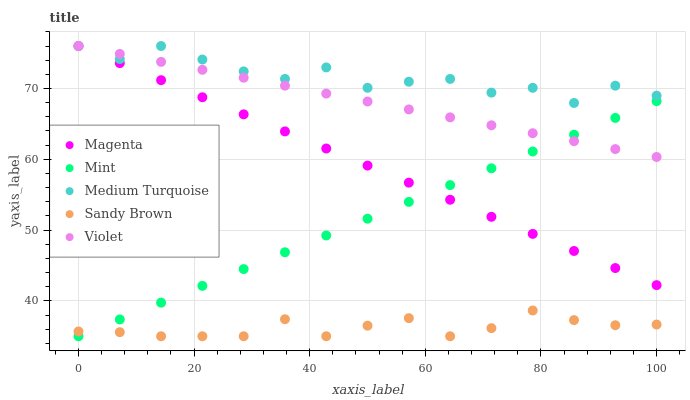Does Sandy Brown have the minimum area under the curve?
Answer yes or no. Yes. Does Medium Turquoise have the maximum area under the curve?
Answer yes or no. Yes. Does Magenta have the minimum area under the curve?
Answer yes or no. No. Does Magenta have the maximum area under the curve?
Answer yes or no. No. Is Magenta the smoothest?
Answer yes or no. Yes. Is Medium Turquoise the roughest?
Answer yes or no. Yes. Is Mint the smoothest?
Answer yes or no. No. Is Mint the roughest?
Answer yes or no. No. Does Sandy Brown have the lowest value?
Answer yes or no. Yes. Does Magenta have the lowest value?
Answer yes or no. No. Does Violet have the highest value?
Answer yes or no. Yes. Does Mint have the highest value?
Answer yes or no. No. Is Sandy Brown less than Violet?
Answer yes or no. Yes. Is Medium Turquoise greater than Sandy Brown?
Answer yes or no. Yes. Does Mint intersect Violet?
Answer yes or no. Yes. Is Mint less than Violet?
Answer yes or no. No. Is Mint greater than Violet?
Answer yes or no. No. Does Sandy Brown intersect Violet?
Answer yes or no. No. 